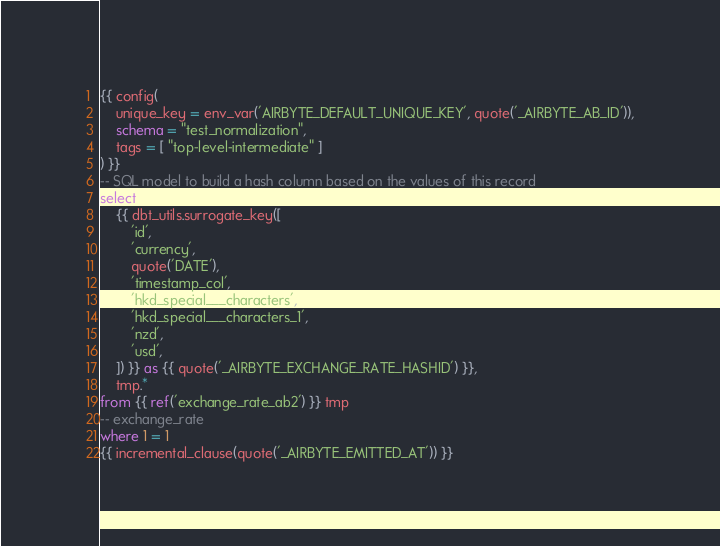Convert code to text. <code><loc_0><loc_0><loc_500><loc_500><_SQL_>{{ config(
    unique_key = env_var('AIRBYTE_DEFAULT_UNIQUE_KEY', quote('_AIRBYTE_AB_ID')),
    schema = "test_normalization",
    tags = [ "top-level-intermediate" ]
) }}
-- SQL model to build a hash column based on the values of this record
select
    {{ dbt_utils.surrogate_key([
        'id',
        'currency',
        quote('DATE'),
        'timestamp_col',
        'hkd_special___characters',
        'hkd_special___characters_1',
        'nzd',
        'usd',
    ]) }} as {{ quote('_AIRBYTE_EXCHANGE_RATE_HASHID') }},
    tmp.*
from {{ ref('exchange_rate_ab2') }} tmp
-- exchange_rate
where 1 = 1
{{ incremental_clause(quote('_AIRBYTE_EMITTED_AT')) }}

</code> 